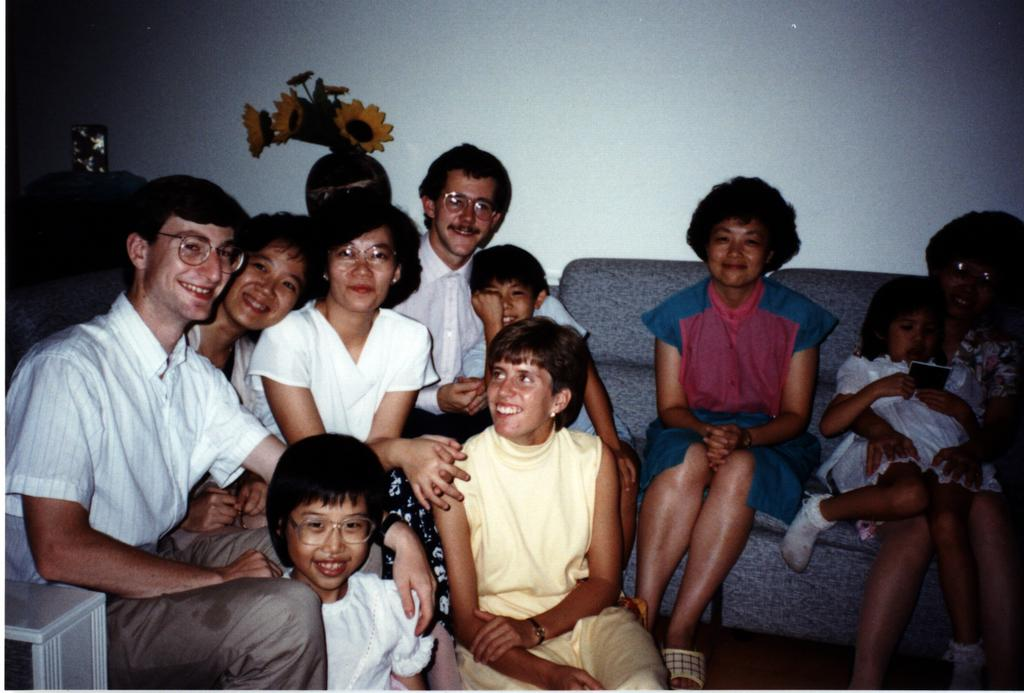What are the people in the image doing? The people in the image are sitting. What object can be seen besides the people in the image? There is a flowerpot in the image. Where is the flowerpot located in relation to other objects in the image? The flowerpot is placed in front of a wall. Can you see any visible veins on the people in the image? There is no information about the people's veins in the image, so it cannot be determined from the image. 